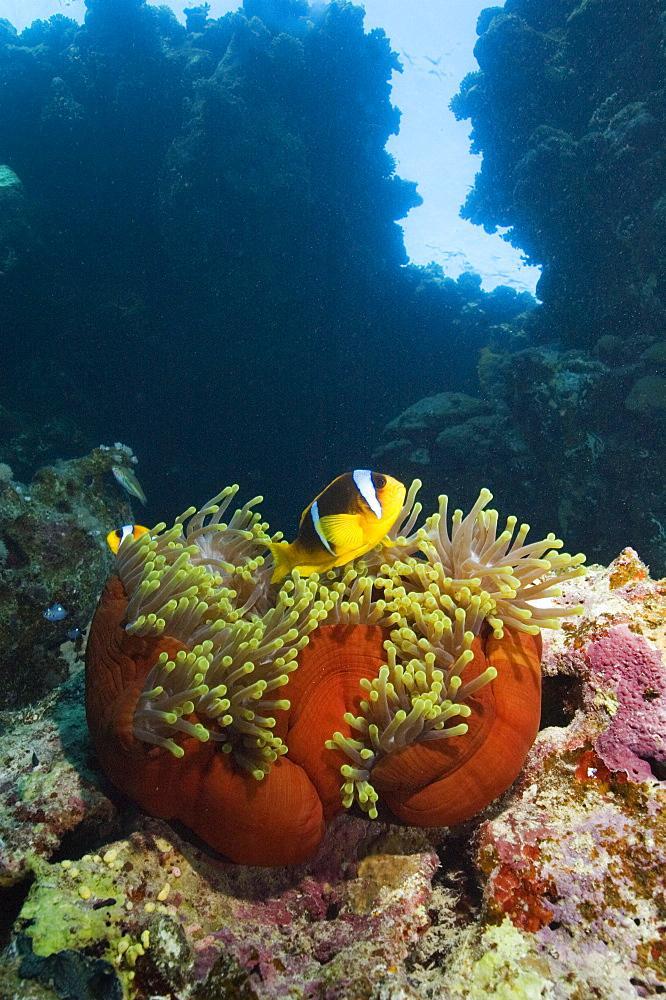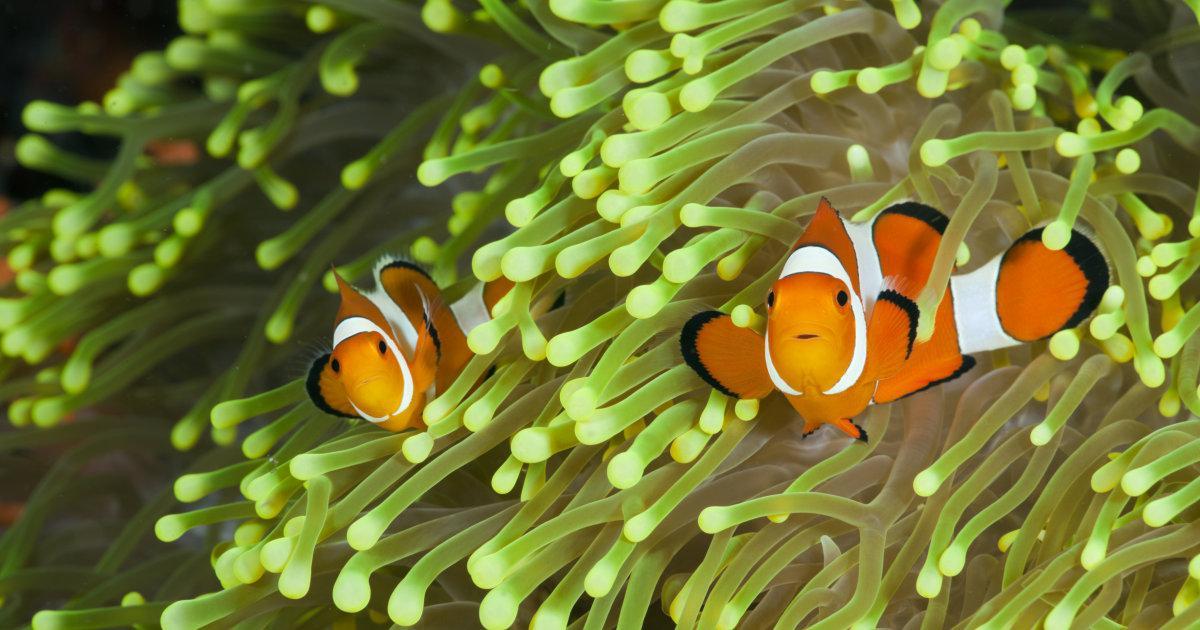The first image is the image on the left, the second image is the image on the right. Assess this claim about the two images: "One image shows orange-and-white clownfish swimming among yellowish tendrils, and the other shows white-striped fish with a bright yellow body.". Correct or not? Answer yes or no. Yes. The first image is the image on the left, the second image is the image on the right. Given the left and right images, does the statement "At least one fish is yellow." hold true? Answer yes or no. Yes. 